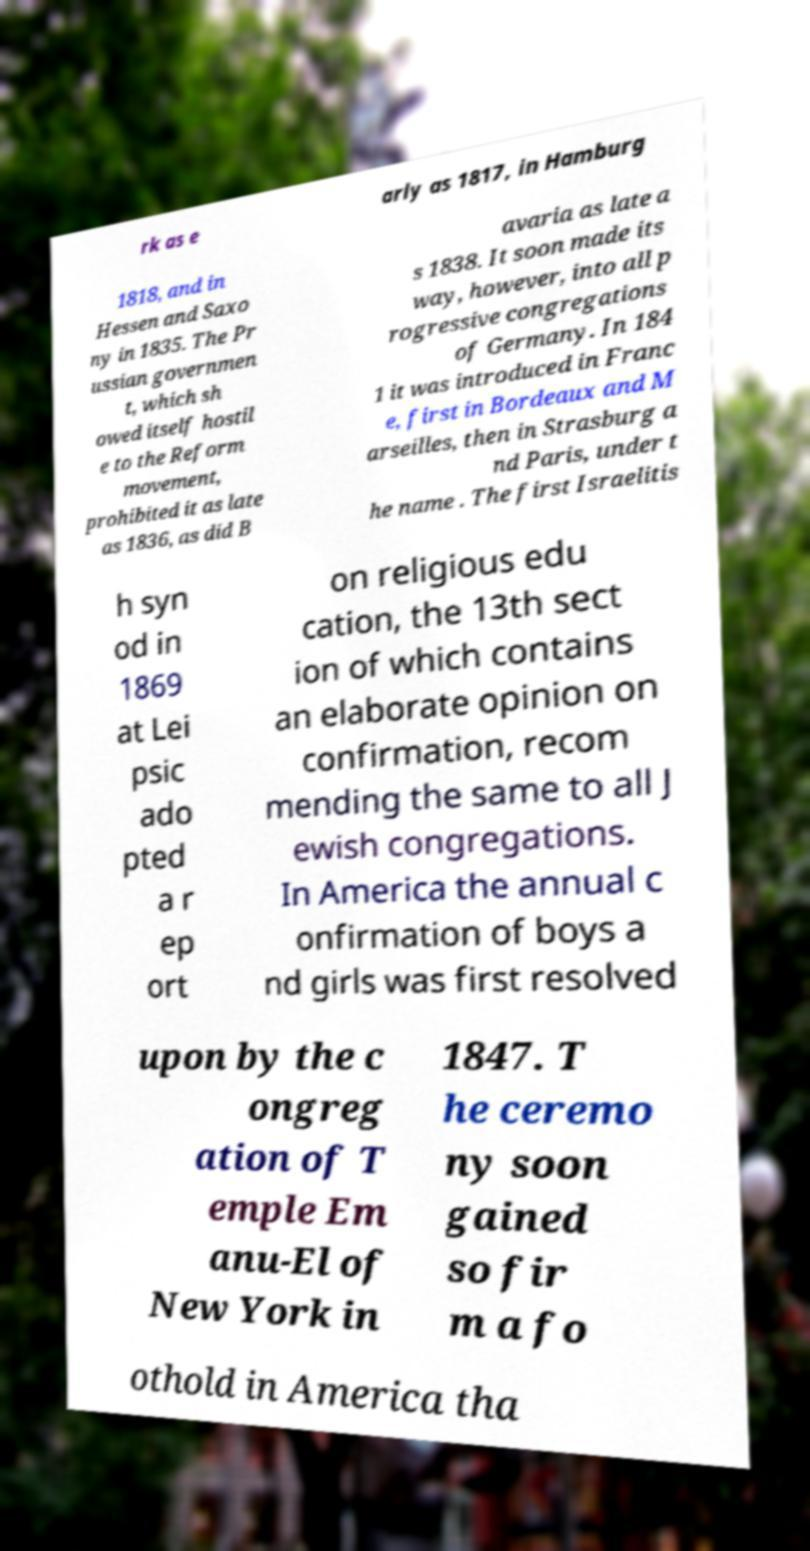What messages or text are displayed in this image? I need them in a readable, typed format. rk as e arly as 1817, in Hamburg 1818, and in Hessen and Saxo ny in 1835. The Pr ussian governmen t, which sh owed itself hostil e to the Reform movement, prohibited it as late as 1836, as did B avaria as late a s 1838. It soon made its way, however, into all p rogressive congregations of Germany. In 184 1 it was introduced in Franc e, first in Bordeaux and M arseilles, then in Strasburg a nd Paris, under t he name . The first Israelitis h syn od in 1869 at Lei psic ado pted a r ep ort on religious edu cation, the 13th sect ion of which contains an elaborate opinion on confirmation, recom mending the same to all J ewish congregations. In America the annual c onfirmation of boys a nd girls was first resolved upon by the c ongreg ation of T emple Em anu-El of New York in 1847. T he ceremo ny soon gained so fir m a fo othold in America tha 